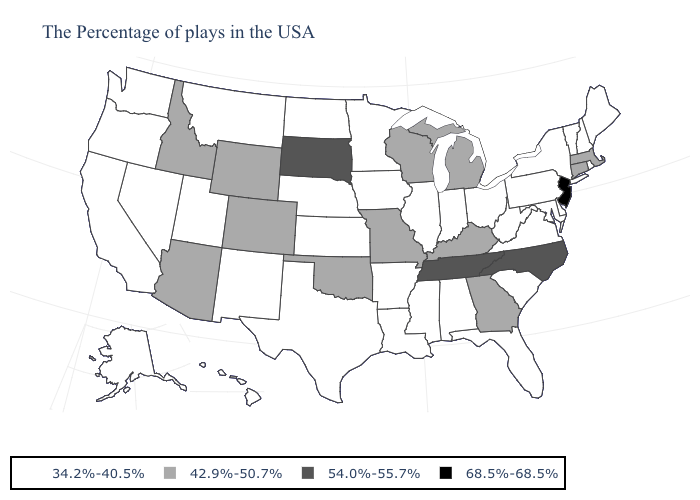Name the states that have a value in the range 34.2%-40.5%?
Write a very short answer. Maine, Rhode Island, New Hampshire, Vermont, New York, Delaware, Maryland, Pennsylvania, Virginia, South Carolina, West Virginia, Ohio, Florida, Indiana, Alabama, Illinois, Mississippi, Louisiana, Arkansas, Minnesota, Iowa, Kansas, Nebraska, Texas, North Dakota, New Mexico, Utah, Montana, Nevada, California, Washington, Oregon, Alaska, Hawaii. Does the map have missing data?
Be succinct. No. Does Kentucky have the highest value in the South?
Write a very short answer. No. Which states have the highest value in the USA?
Answer briefly. New Jersey. Name the states that have a value in the range 34.2%-40.5%?
Short answer required. Maine, Rhode Island, New Hampshire, Vermont, New York, Delaware, Maryland, Pennsylvania, Virginia, South Carolina, West Virginia, Ohio, Florida, Indiana, Alabama, Illinois, Mississippi, Louisiana, Arkansas, Minnesota, Iowa, Kansas, Nebraska, Texas, North Dakota, New Mexico, Utah, Montana, Nevada, California, Washington, Oregon, Alaska, Hawaii. What is the value of Arizona?
Concise answer only. 42.9%-50.7%. Among the states that border New Mexico , does Texas have the lowest value?
Write a very short answer. Yes. Does West Virginia have a higher value than Louisiana?
Keep it brief. No. Name the states that have a value in the range 34.2%-40.5%?
Short answer required. Maine, Rhode Island, New Hampshire, Vermont, New York, Delaware, Maryland, Pennsylvania, Virginia, South Carolina, West Virginia, Ohio, Florida, Indiana, Alabama, Illinois, Mississippi, Louisiana, Arkansas, Minnesota, Iowa, Kansas, Nebraska, Texas, North Dakota, New Mexico, Utah, Montana, Nevada, California, Washington, Oregon, Alaska, Hawaii. Does Colorado have the highest value in the USA?
Short answer required. No. Name the states that have a value in the range 54.0%-55.7%?
Answer briefly. North Carolina, Tennessee, South Dakota. Among the states that border Utah , does Arizona have the highest value?
Be succinct. Yes. What is the highest value in the USA?
Keep it brief. 68.5%-68.5%. Name the states that have a value in the range 68.5%-68.5%?
Concise answer only. New Jersey. What is the value of New Jersey?
Give a very brief answer. 68.5%-68.5%. 